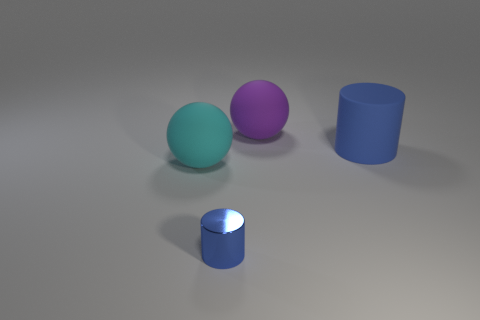Add 3 tiny cyan matte objects. How many objects exist? 7 Subtract all blue shiny things. Subtract all small red matte objects. How many objects are left? 3 Add 2 matte objects. How many matte objects are left? 5 Add 1 blue metal objects. How many blue metal objects exist? 2 Subtract 0 cyan cylinders. How many objects are left? 4 